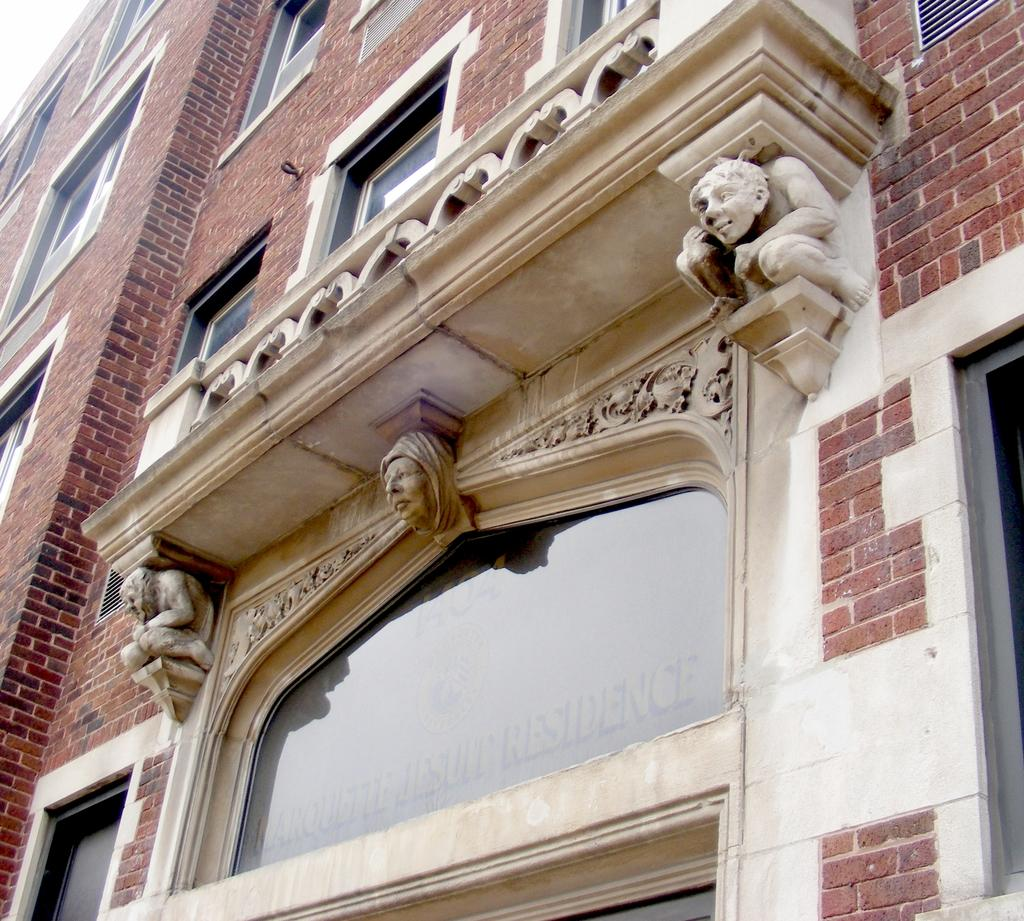What type of structure is visible in the image? There is a building in the image. What feature can be seen on the building? The building has windows. Are there any decorative elements on the building? Yes, there are carved sculptures on the wall of the building. Can you tell me where the donkey is located in the image? There is no donkey present in the image. What type of store is located inside the building in the image? The image does not provide information about any store inside the building. 